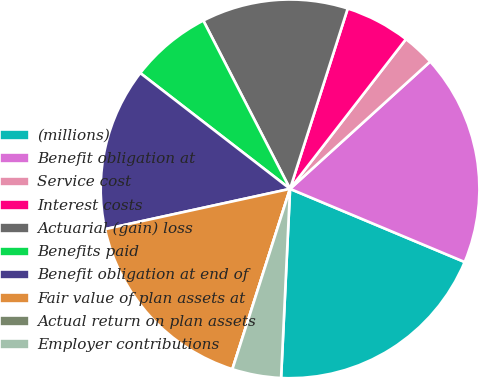<chart> <loc_0><loc_0><loc_500><loc_500><pie_chart><fcel>(millions)<fcel>Benefit obligation at<fcel>Service cost<fcel>Interest costs<fcel>Actuarial (gain) loss<fcel>Benefits paid<fcel>Benefit obligation at end of<fcel>Fair value of plan assets at<fcel>Actual return on plan assets<fcel>Employer contributions<nl><fcel>19.44%<fcel>18.05%<fcel>2.78%<fcel>5.56%<fcel>12.5%<fcel>6.95%<fcel>13.89%<fcel>16.66%<fcel>0.0%<fcel>4.17%<nl></chart> 